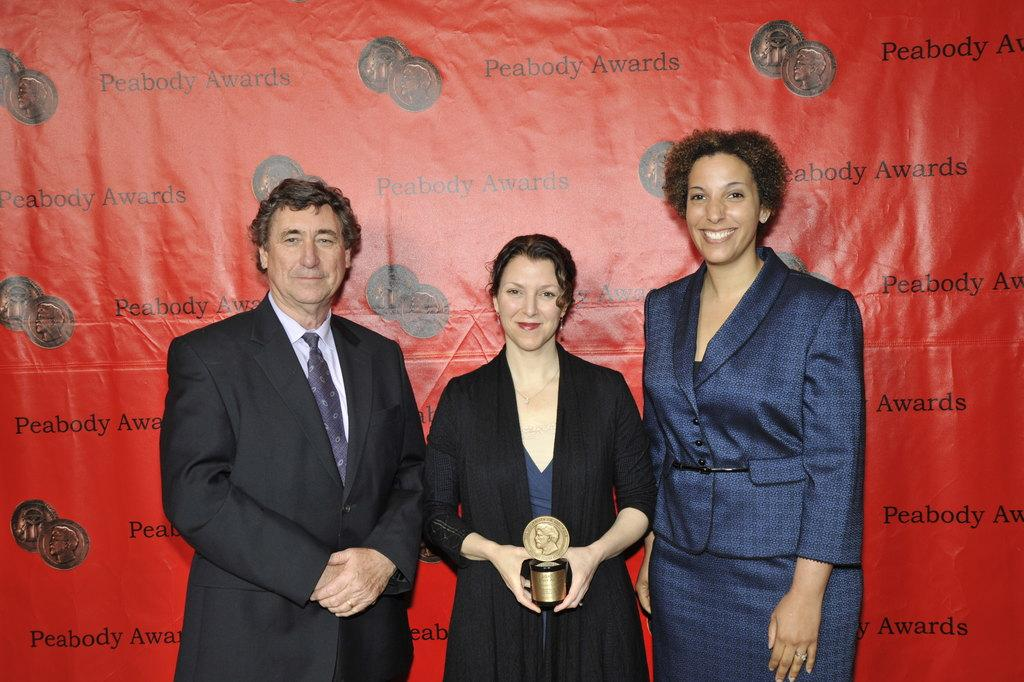How many people are in the foreground of the picture? There are three people standing in the foreground of the picture. Can you describe the woman's position in the picture? The woman is in the center of the picture. What is the woman holding in the picture? The woman is holding an object. What color is the banner visible in the background of the picture? There is a red color banner in the background of the picture. How many dogs are visible in the picture? There are no dogs present in the picture. What type of quill is the woman using to write on the hand in the picture? There is no quill or hand visible in the picture; the woman is holding an unspecified object. 